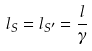Convert formula to latex. <formula><loc_0><loc_0><loc_500><loc_500>l _ { S } = l _ { S ^ { \prime } } = \frac { l } { \gamma }</formula> 